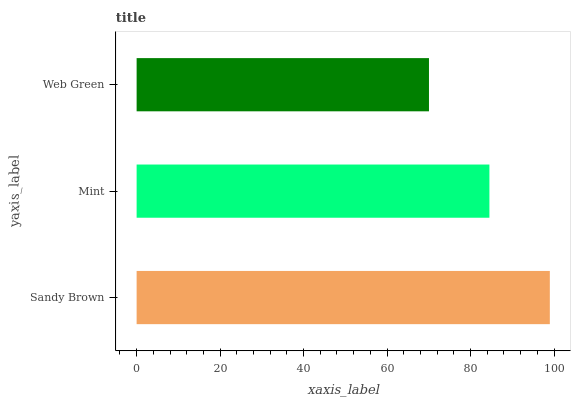Is Web Green the minimum?
Answer yes or no. Yes. Is Sandy Brown the maximum?
Answer yes or no. Yes. Is Mint the minimum?
Answer yes or no. No. Is Mint the maximum?
Answer yes or no. No. Is Sandy Brown greater than Mint?
Answer yes or no. Yes. Is Mint less than Sandy Brown?
Answer yes or no. Yes. Is Mint greater than Sandy Brown?
Answer yes or no. No. Is Sandy Brown less than Mint?
Answer yes or no. No. Is Mint the high median?
Answer yes or no. Yes. Is Mint the low median?
Answer yes or no. Yes. Is Web Green the high median?
Answer yes or no. No. Is Sandy Brown the low median?
Answer yes or no. No. 